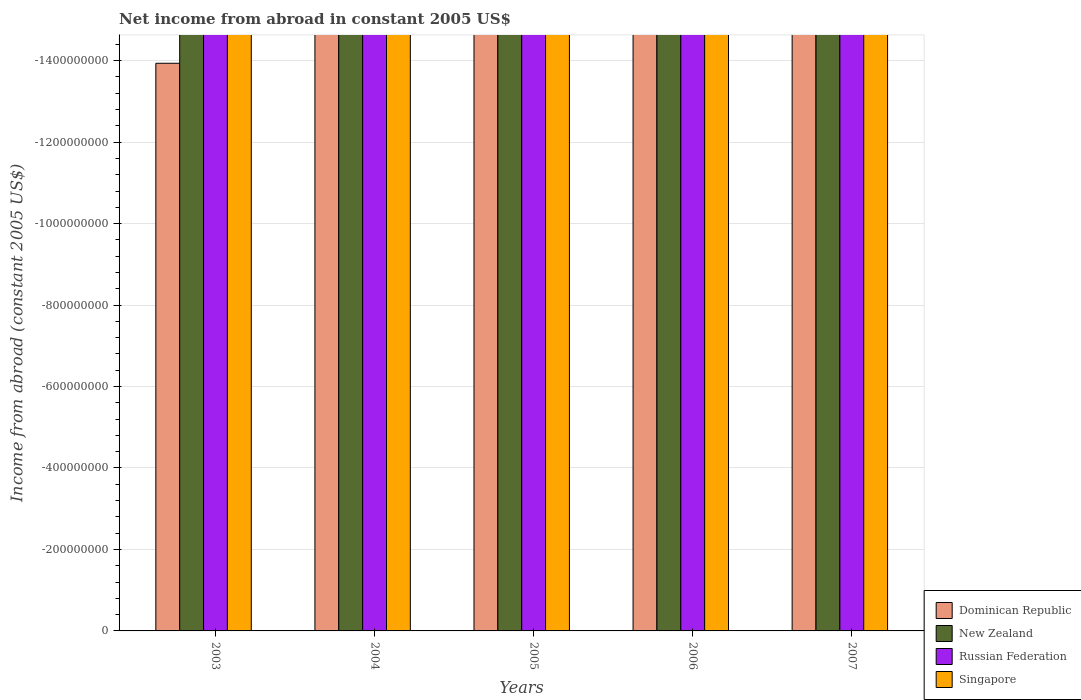How many different coloured bars are there?
Offer a very short reply. 0. How many bars are there on the 5th tick from the left?
Make the answer very short. 0. How many bars are there on the 4th tick from the right?
Provide a succinct answer. 0. What is the net income from abroad in Russian Federation in 2004?
Make the answer very short. 0. Across all years, what is the minimum net income from abroad in Singapore?
Offer a very short reply. 0. What is the total net income from abroad in New Zealand in the graph?
Provide a short and direct response. 0. What is the difference between the net income from abroad in New Zealand in 2005 and the net income from abroad in Singapore in 2004?
Offer a very short reply. 0. In how many years, is the net income from abroad in Russian Federation greater than -320000000 US$?
Make the answer very short. 0. How many bars are there?
Your answer should be very brief. 0. Are all the bars in the graph horizontal?
Offer a very short reply. No. How many years are there in the graph?
Ensure brevity in your answer.  5. What is the difference between two consecutive major ticks on the Y-axis?
Make the answer very short. 2.00e+08. Are the values on the major ticks of Y-axis written in scientific E-notation?
Offer a terse response. No. Does the graph contain any zero values?
Your answer should be very brief. Yes. Does the graph contain grids?
Provide a short and direct response. Yes. Where does the legend appear in the graph?
Your answer should be compact. Bottom right. What is the title of the graph?
Ensure brevity in your answer.  Net income from abroad in constant 2005 US$. What is the label or title of the X-axis?
Offer a very short reply. Years. What is the label or title of the Y-axis?
Your response must be concise. Income from abroad (constant 2005 US$). What is the Income from abroad (constant 2005 US$) of New Zealand in 2003?
Keep it short and to the point. 0. What is the Income from abroad (constant 2005 US$) of Russian Federation in 2003?
Your answer should be compact. 0. What is the Income from abroad (constant 2005 US$) of Singapore in 2003?
Your answer should be compact. 0. What is the Income from abroad (constant 2005 US$) of Dominican Republic in 2005?
Give a very brief answer. 0. What is the Income from abroad (constant 2005 US$) in Russian Federation in 2005?
Your answer should be compact. 0. What is the Income from abroad (constant 2005 US$) in Singapore in 2005?
Your answer should be very brief. 0. What is the Income from abroad (constant 2005 US$) in New Zealand in 2006?
Your answer should be compact. 0. What is the Income from abroad (constant 2005 US$) of Russian Federation in 2006?
Your answer should be compact. 0. What is the Income from abroad (constant 2005 US$) of Singapore in 2006?
Ensure brevity in your answer.  0. What is the Income from abroad (constant 2005 US$) of Russian Federation in 2007?
Offer a very short reply. 0. What is the total Income from abroad (constant 2005 US$) in Dominican Republic in the graph?
Give a very brief answer. 0. What is the total Income from abroad (constant 2005 US$) of Singapore in the graph?
Keep it short and to the point. 0. What is the average Income from abroad (constant 2005 US$) in Russian Federation per year?
Your response must be concise. 0. 